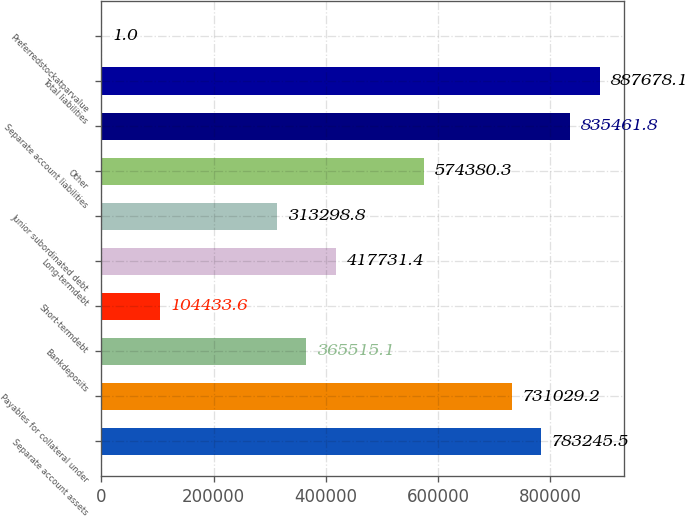Convert chart. <chart><loc_0><loc_0><loc_500><loc_500><bar_chart><fcel>Separate account assets<fcel>Payables for collateral under<fcel>Bankdeposits<fcel>Short-termdebt<fcel>Long-termdebt<fcel>Junior subordinated debt<fcel>Other<fcel>Separate account liabilities<fcel>Total liabilities<fcel>Preferredstockatparvalue<nl><fcel>783246<fcel>731029<fcel>365515<fcel>104434<fcel>417731<fcel>313299<fcel>574380<fcel>835462<fcel>887678<fcel>1<nl></chart> 